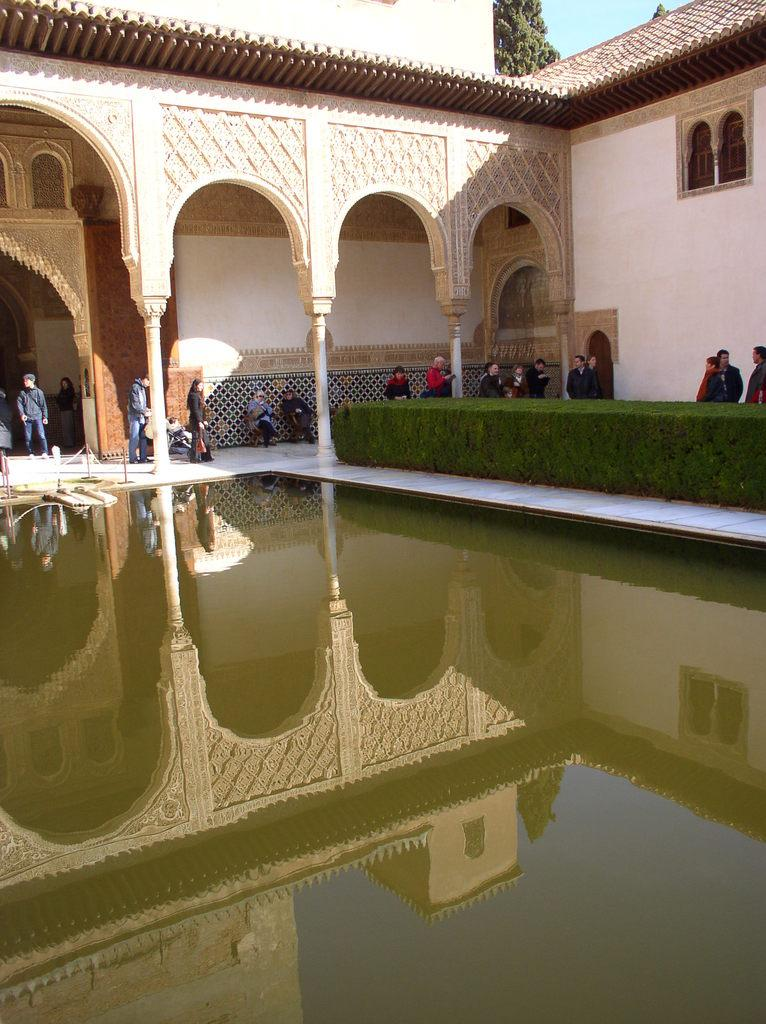What type of structure is visible in the image? There is a building in the image. What is located in front of the building? There is a pool and plants in front of the building. Can you describe the people in the image? People are moving and standing in the image. What can be seen in the background of the image? There are trees in the background of the image. Where can the oranges be found in the image? There are no oranges present in the image. Is there a camp set up in the background of the image? There is no camp visible in the image; only trees are present in the background. 